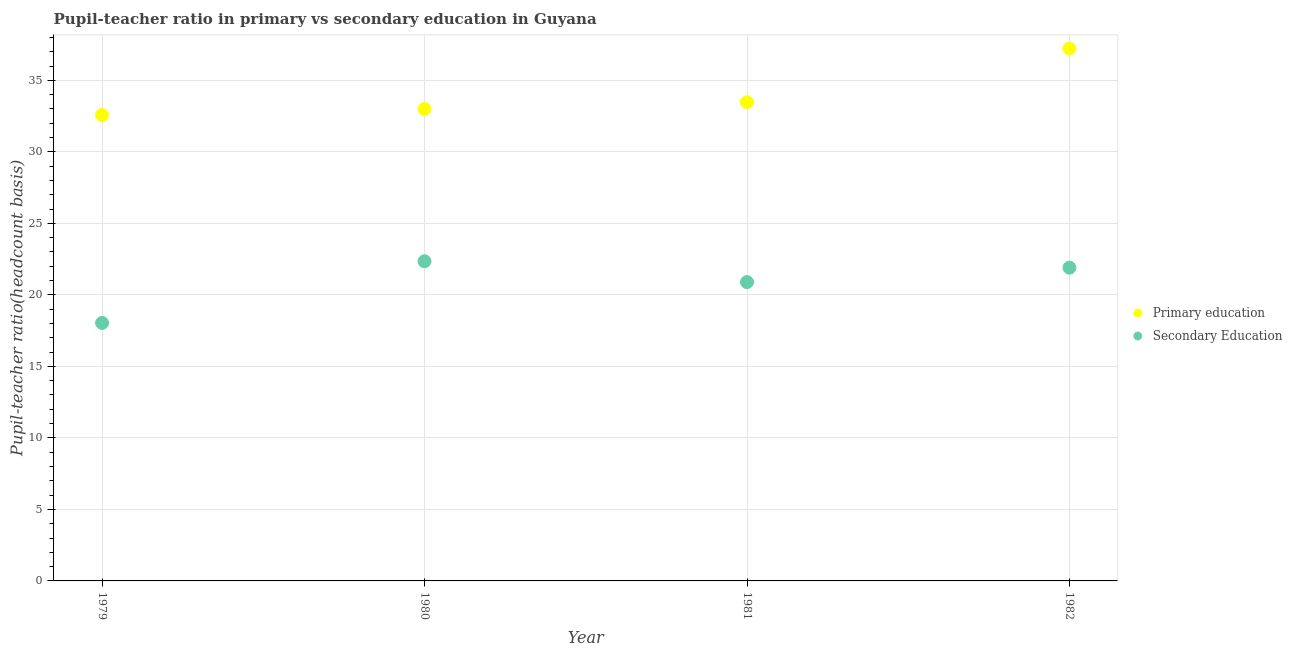How many different coloured dotlines are there?
Provide a succinct answer. 2. Is the number of dotlines equal to the number of legend labels?
Ensure brevity in your answer.  Yes. What is the pupil teacher ratio on secondary education in 1979?
Your answer should be very brief. 18.04. Across all years, what is the maximum pupil teacher ratio on secondary education?
Provide a succinct answer. 22.35. Across all years, what is the minimum pupil-teacher ratio in primary education?
Ensure brevity in your answer.  32.58. In which year was the pupil teacher ratio on secondary education maximum?
Offer a very short reply. 1980. In which year was the pupil teacher ratio on secondary education minimum?
Keep it short and to the point. 1979. What is the total pupil-teacher ratio in primary education in the graph?
Provide a succinct answer. 136.26. What is the difference between the pupil-teacher ratio in primary education in 1980 and that in 1982?
Your response must be concise. -4.22. What is the difference between the pupil teacher ratio on secondary education in 1982 and the pupil-teacher ratio in primary education in 1979?
Keep it short and to the point. -10.68. What is the average pupil teacher ratio on secondary education per year?
Ensure brevity in your answer.  20.8. In the year 1981, what is the difference between the pupil teacher ratio on secondary education and pupil-teacher ratio in primary education?
Your answer should be compact. -12.58. In how many years, is the pupil-teacher ratio in primary education greater than 20?
Provide a short and direct response. 4. What is the ratio of the pupil teacher ratio on secondary education in 1980 to that in 1982?
Offer a very short reply. 1.02. Is the difference between the pupil-teacher ratio in primary education in 1981 and 1982 greater than the difference between the pupil teacher ratio on secondary education in 1981 and 1982?
Provide a short and direct response. No. What is the difference between the highest and the second highest pupil-teacher ratio in primary education?
Keep it short and to the point. 3.75. What is the difference between the highest and the lowest pupil-teacher ratio in primary education?
Keep it short and to the point. 4.64. In how many years, is the pupil teacher ratio on secondary education greater than the average pupil teacher ratio on secondary education taken over all years?
Give a very brief answer. 3. Does the pupil-teacher ratio in primary education monotonically increase over the years?
Offer a terse response. Yes. Is the pupil-teacher ratio in primary education strictly greater than the pupil teacher ratio on secondary education over the years?
Your response must be concise. Yes. Is the pupil teacher ratio on secondary education strictly less than the pupil-teacher ratio in primary education over the years?
Your answer should be very brief. Yes. Does the graph contain grids?
Provide a short and direct response. Yes. How many legend labels are there?
Keep it short and to the point. 2. How are the legend labels stacked?
Provide a succinct answer. Vertical. What is the title of the graph?
Keep it short and to the point. Pupil-teacher ratio in primary vs secondary education in Guyana. Does "Working only" appear as one of the legend labels in the graph?
Make the answer very short. No. What is the label or title of the X-axis?
Ensure brevity in your answer.  Year. What is the label or title of the Y-axis?
Offer a terse response. Pupil-teacher ratio(headcount basis). What is the Pupil-teacher ratio(headcount basis) of Primary education in 1979?
Provide a succinct answer. 32.58. What is the Pupil-teacher ratio(headcount basis) in Secondary Education in 1979?
Your answer should be compact. 18.04. What is the Pupil-teacher ratio(headcount basis) of Primary education in 1980?
Provide a succinct answer. 32.99. What is the Pupil-teacher ratio(headcount basis) in Secondary Education in 1980?
Offer a terse response. 22.35. What is the Pupil-teacher ratio(headcount basis) in Primary education in 1981?
Your answer should be compact. 33.47. What is the Pupil-teacher ratio(headcount basis) of Secondary Education in 1981?
Your answer should be very brief. 20.89. What is the Pupil-teacher ratio(headcount basis) in Primary education in 1982?
Offer a very short reply. 37.22. What is the Pupil-teacher ratio(headcount basis) of Secondary Education in 1982?
Your answer should be very brief. 21.9. Across all years, what is the maximum Pupil-teacher ratio(headcount basis) of Primary education?
Keep it short and to the point. 37.22. Across all years, what is the maximum Pupil-teacher ratio(headcount basis) of Secondary Education?
Offer a very short reply. 22.35. Across all years, what is the minimum Pupil-teacher ratio(headcount basis) of Primary education?
Keep it short and to the point. 32.58. Across all years, what is the minimum Pupil-teacher ratio(headcount basis) in Secondary Education?
Make the answer very short. 18.04. What is the total Pupil-teacher ratio(headcount basis) in Primary education in the graph?
Your answer should be very brief. 136.26. What is the total Pupil-teacher ratio(headcount basis) in Secondary Education in the graph?
Make the answer very short. 83.18. What is the difference between the Pupil-teacher ratio(headcount basis) of Primary education in 1979 and that in 1980?
Provide a short and direct response. -0.42. What is the difference between the Pupil-teacher ratio(headcount basis) in Secondary Education in 1979 and that in 1980?
Offer a very short reply. -4.31. What is the difference between the Pupil-teacher ratio(headcount basis) in Primary education in 1979 and that in 1981?
Give a very brief answer. -0.89. What is the difference between the Pupil-teacher ratio(headcount basis) of Secondary Education in 1979 and that in 1981?
Ensure brevity in your answer.  -2.86. What is the difference between the Pupil-teacher ratio(headcount basis) of Primary education in 1979 and that in 1982?
Your answer should be very brief. -4.64. What is the difference between the Pupil-teacher ratio(headcount basis) in Secondary Education in 1979 and that in 1982?
Make the answer very short. -3.86. What is the difference between the Pupil-teacher ratio(headcount basis) in Primary education in 1980 and that in 1981?
Offer a very short reply. -0.48. What is the difference between the Pupil-teacher ratio(headcount basis) of Secondary Education in 1980 and that in 1981?
Offer a terse response. 1.46. What is the difference between the Pupil-teacher ratio(headcount basis) of Primary education in 1980 and that in 1982?
Your answer should be very brief. -4.22. What is the difference between the Pupil-teacher ratio(headcount basis) in Secondary Education in 1980 and that in 1982?
Offer a terse response. 0.45. What is the difference between the Pupil-teacher ratio(headcount basis) of Primary education in 1981 and that in 1982?
Your answer should be very brief. -3.75. What is the difference between the Pupil-teacher ratio(headcount basis) of Secondary Education in 1981 and that in 1982?
Offer a very short reply. -1.01. What is the difference between the Pupil-teacher ratio(headcount basis) of Primary education in 1979 and the Pupil-teacher ratio(headcount basis) of Secondary Education in 1980?
Offer a very short reply. 10.23. What is the difference between the Pupil-teacher ratio(headcount basis) in Primary education in 1979 and the Pupil-teacher ratio(headcount basis) in Secondary Education in 1981?
Provide a succinct answer. 11.68. What is the difference between the Pupil-teacher ratio(headcount basis) in Primary education in 1979 and the Pupil-teacher ratio(headcount basis) in Secondary Education in 1982?
Your answer should be compact. 10.68. What is the difference between the Pupil-teacher ratio(headcount basis) of Primary education in 1980 and the Pupil-teacher ratio(headcount basis) of Secondary Education in 1981?
Give a very brief answer. 12.1. What is the difference between the Pupil-teacher ratio(headcount basis) of Primary education in 1980 and the Pupil-teacher ratio(headcount basis) of Secondary Education in 1982?
Give a very brief answer. 11.09. What is the difference between the Pupil-teacher ratio(headcount basis) in Primary education in 1981 and the Pupil-teacher ratio(headcount basis) in Secondary Education in 1982?
Your response must be concise. 11.57. What is the average Pupil-teacher ratio(headcount basis) of Primary education per year?
Your answer should be very brief. 34.06. What is the average Pupil-teacher ratio(headcount basis) of Secondary Education per year?
Your response must be concise. 20.8. In the year 1979, what is the difference between the Pupil-teacher ratio(headcount basis) of Primary education and Pupil-teacher ratio(headcount basis) of Secondary Education?
Your response must be concise. 14.54. In the year 1980, what is the difference between the Pupil-teacher ratio(headcount basis) in Primary education and Pupil-teacher ratio(headcount basis) in Secondary Education?
Provide a succinct answer. 10.64. In the year 1981, what is the difference between the Pupil-teacher ratio(headcount basis) in Primary education and Pupil-teacher ratio(headcount basis) in Secondary Education?
Ensure brevity in your answer.  12.58. In the year 1982, what is the difference between the Pupil-teacher ratio(headcount basis) in Primary education and Pupil-teacher ratio(headcount basis) in Secondary Education?
Your answer should be compact. 15.32. What is the ratio of the Pupil-teacher ratio(headcount basis) in Primary education in 1979 to that in 1980?
Your answer should be compact. 0.99. What is the ratio of the Pupil-teacher ratio(headcount basis) of Secondary Education in 1979 to that in 1980?
Your response must be concise. 0.81. What is the ratio of the Pupil-teacher ratio(headcount basis) of Primary education in 1979 to that in 1981?
Your response must be concise. 0.97. What is the ratio of the Pupil-teacher ratio(headcount basis) of Secondary Education in 1979 to that in 1981?
Offer a terse response. 0.86. What is the ratio of the Pupil-teacher ratio(headcount basis) in Primary education in 1979 to that in 1982?
Offer a terse response. 0.88. What is the ratio of the Pupil-teacher ratio(headcount basis) in Secondary Education in 1979 to that in 1982?
Your response must be concise. 0.82. What is the ratio of the Pupil-teacher ratio(headcount basis) in Primary education in 1980 to that in 1981?
Provide a short and direct response. 0.99. What is the ratio of the Pupil-teacher ratio(headcount basis) in Secondary Education in 1980 to that in 1981?
Offer a very short reply. 1.07. What is the ratio of the Pupil-teacher ratio(headcount basis) in Primary education in 1980 to that in 1982?
Offer a terse response. 0.89. What is the ratio of the Pupil-teacher ratio(headcount basis) in Secondary Education in 1980 to that in 1982?
Provide a short and direct response. 1.02. What is the ratio of the Pupil-teacher ratio(headcount basis) in Primary education in 1981 to that in 1982?
Keep it short and to the point. 0.9. What is the ratio of the Pupil-teacher ratio(headcount basis) of Secondary Education in 1981 to that in 1982?
Provide a succinct answer. 0.95. What is the difference between the highest and the second highest Pupil-teacher ratio(headcount basis) in Primary education?
Provide a short and direct response. 3.75. What is the difference between the highest and the second highest Pupil-teacher ratio(headcount basis) in Secondary Education?
Offer a very short reply. 0.45. What is the difference between the highest and the lowest Pupil-teacher ratio(headcount basis) of Primary education?
Offer a very short reply. 4.64. What is the difference between the highest and the lowest Pupil-teacher ratio(headcount basis) of Secondary Education?
Give a very brief answer. 4.31. 